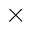<formula> <loc_0><loc_0><loc_500><loc_500>\times</formula> 